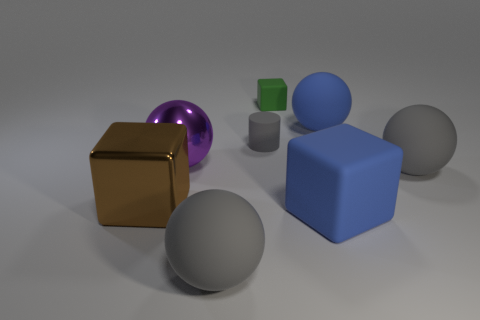What number of objects are either large rubber things to the left of the big blue rubber sphere or large shiny balls?
Offer a terse response. 3. Are there more big rubber blocks to the right of the blue matte sphere than gray cylinders that are behind the gray rubber cylinder?
Your response must be concise. No. What number of metallic objects are blue blocks or large gray cylinders?
Your response must be concise. 0. What is the material of the thing that is the same color as the large matte cube?
Ensure brevity in your answer.  Rubber. Are there fewer purple metallic balls that are in front of the blue matte ball than big rubber blocks that are on the left side of the brown shiny object?
Your answer should be compact. No. How many things are big metallic spheres or spheres that are in front of the big purple object?
Offer a very short reply. 3. There is a blue block that is the same size as the brown metallic thing; what is it made of?
Offer a very short reply. Rubber. Do the large purple ball and the big blue cube have the same material?
Offer a very short reply. No. There is a matte ball that is both in front of the large blue matte ball and behind the blue cube; what color is it?
Your response must be concise. Gray. There is a large matte object that is behind the matte cylinder; does it have the same color as the tiny cylinder?
Keep it short and to the point. No. 